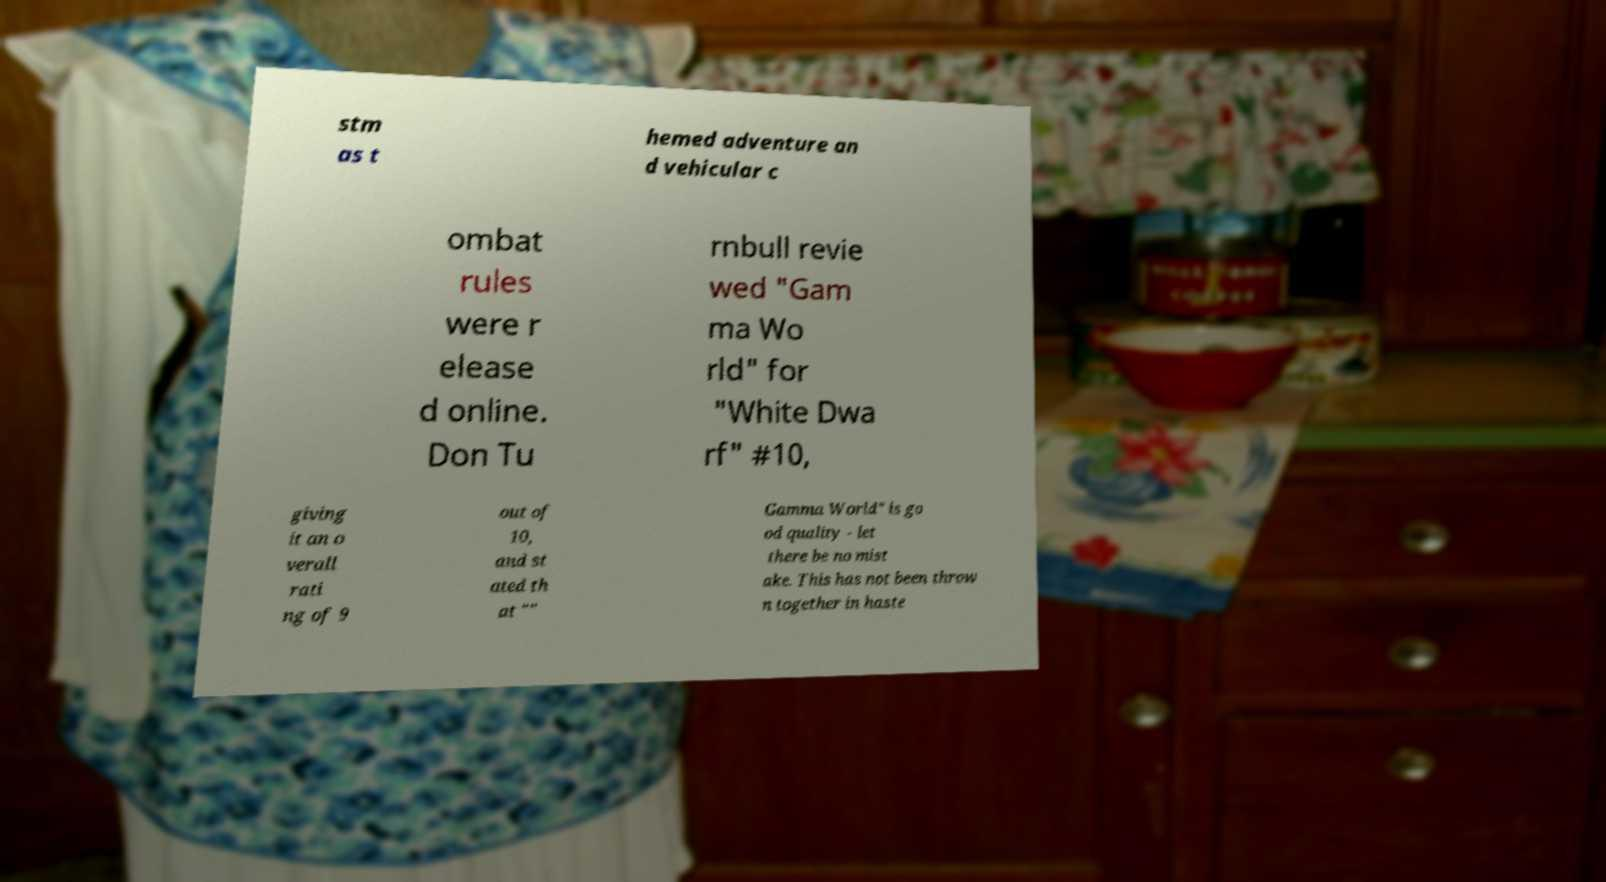I need the written content from this picture converted into text. Can you do that? stm as t hemed adventure an d vehicular c ombat rules were r elease d online. Don Tu rnbull revie wed "Gam ma Wo rld" for "White Dwa rf" #10, giving it an o verall rati ng of 9 out of 10, and st ated th at "" Gamma World" is go od quality - let there be no mist ake. This has not been throw n together in haste 